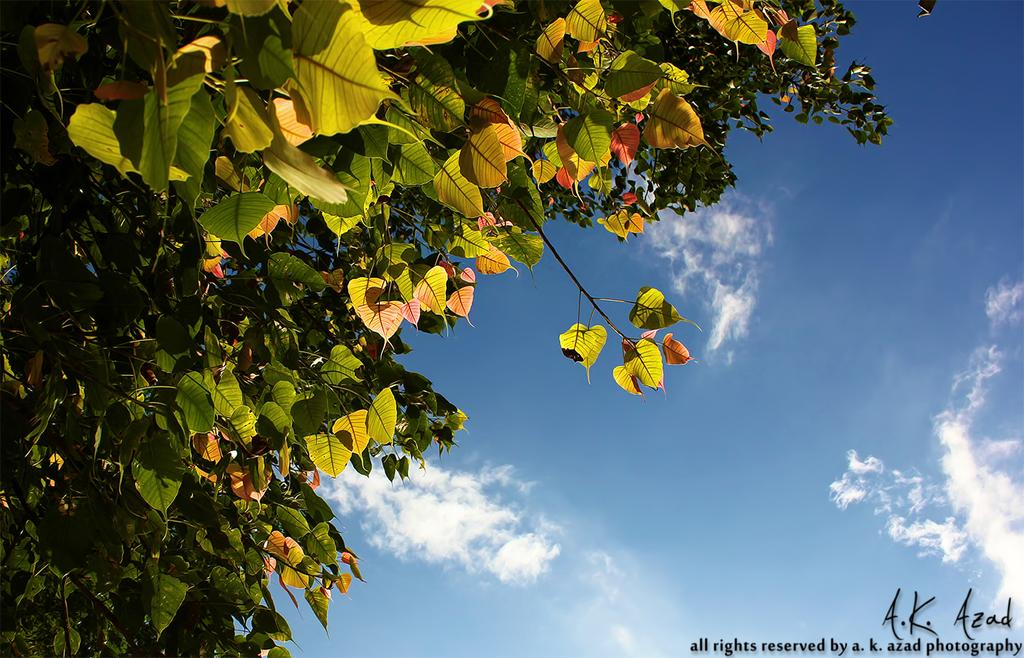What can be found in the bottom right corner of the image? There is a watermark in the bottom right of the image. What type of vegetation is on the left side of the image? There are trees on the left side of the image. What is visible in the background of the image? There are clouds in the background of the image. What color is the sky in the image? The sky is blue in the image. What type of button can be seen on the apparatus in the image? There is no apparatus or button present in the image. How does the expansion of the clouds affect the image? The image does not depict the expansion of clouds; it shows clouds that are already present in the background. 